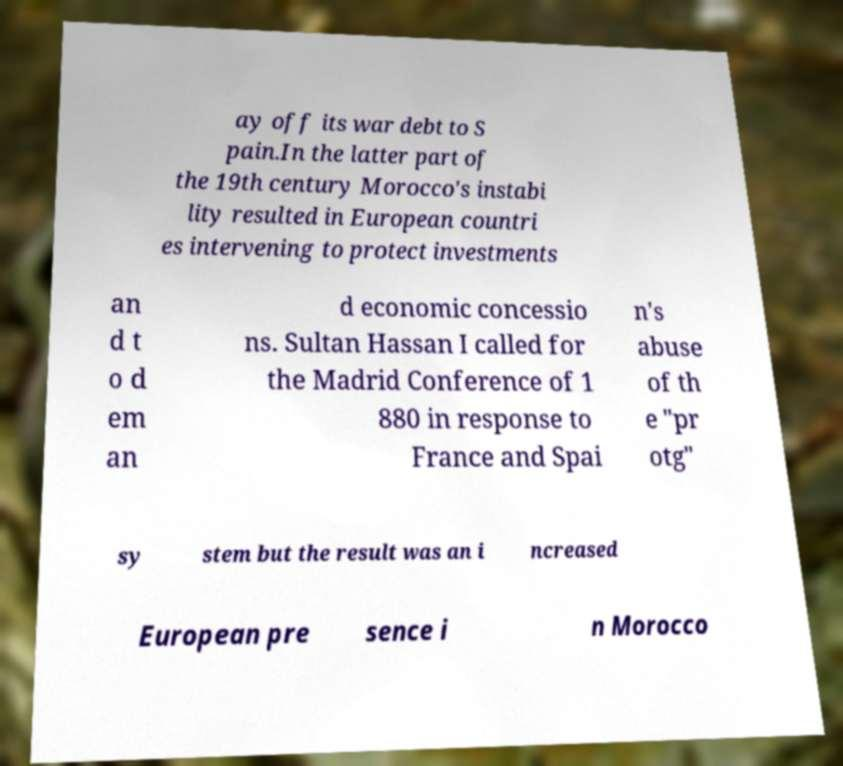Could you assist in decoding the text presented in this image and type it out clearly? ay off its war debt to S pain.In the latter part of the 19th century Morocco's instabi lity resulted in European countri es intervening to protect investments an d t o d em an d economic concessio ns. Sultan Hassan I called for the Madrid Conference of 1 880 in response to France and Spai n's abuse of th e "pr otg" sy stem but the result was an i ncreased European pre sence i n Morocco 